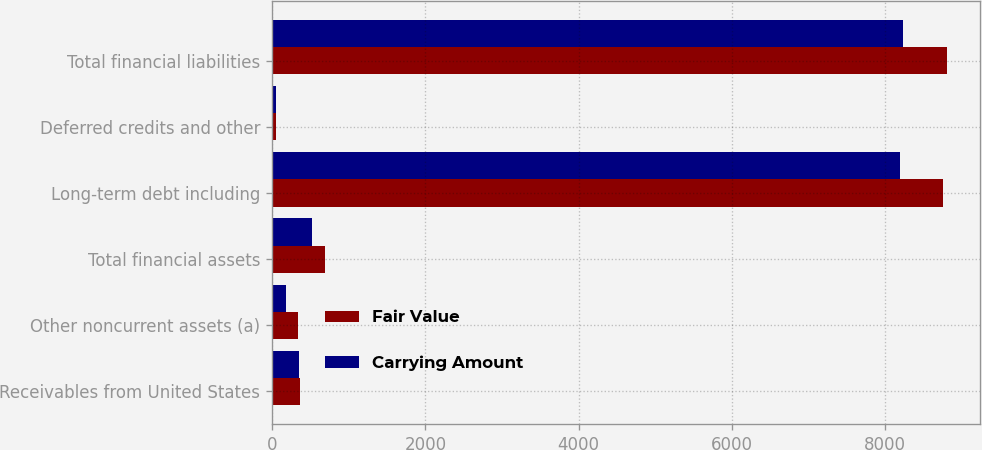Convert chart to OTSL. <chart><loc_0><loc_0><loc_500><loc_500><stacked_bar_chart><ecel><fcel>Receivables from United States<fcel>Other noncurrent assets (a)<fcel>Total financial assets<fcel>Long-term debt including<fcel>Deferred credits and other<fcel>Total financial liabilities<nl><fcel>Fair Value<fcel>360<fcel>334<fcel>694<fcel>8754<fcel>49<fcel>8803<nl><fcel>Carrying Amount<fcel>346<fcel>178<fcel>524<fcel>8190<fcel>49<fcel>8239<nl></chart> 